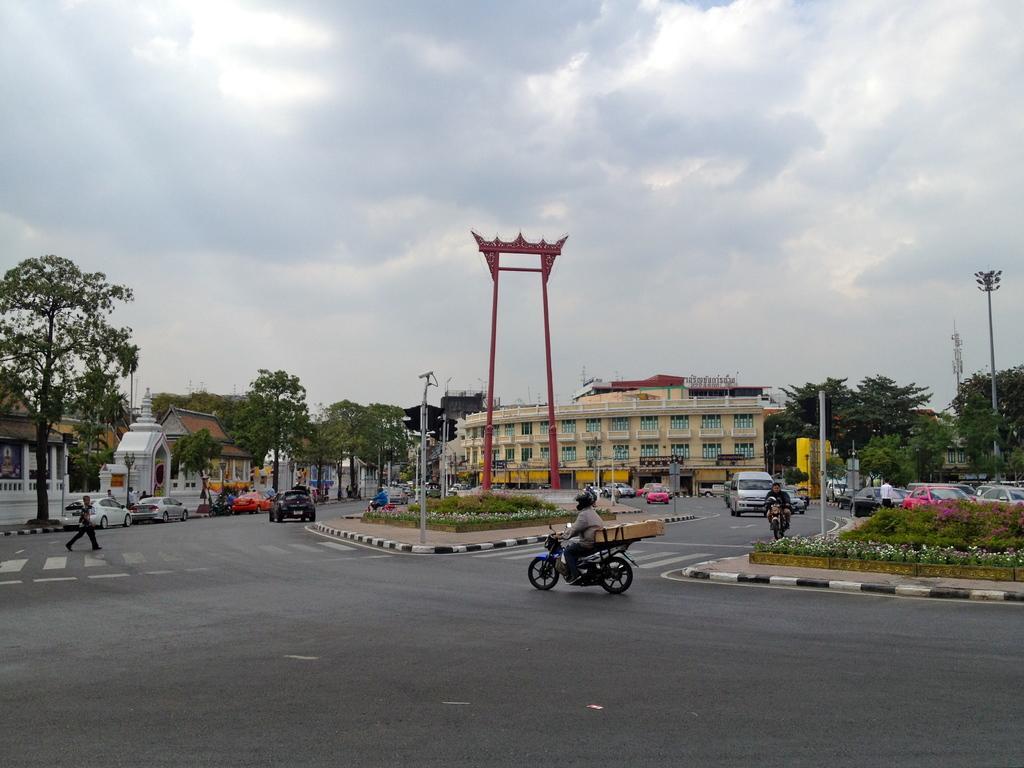Please provide a concise description of this image. This is an outside view. At the bottom there is a road and I can see many vehicles on this road. In the background there are many buildings and trees and also I can see the poles. At the top of the image I can see the sky. 